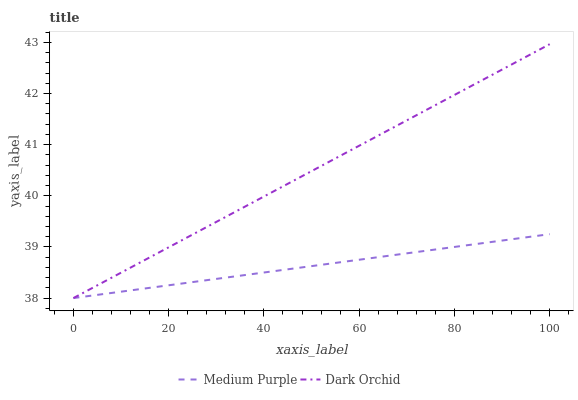Does Medium Purple have the minimum area under the curve?
Answer yes or no. Yes. Does Dark Orchid have the maximum area under the curve?
Answer yes or no. Yes. Does Dark Orchid have the minimum area under the curve?
Answer yes or no. No. Is Medium Purple the smoothest?
Answer yes or no. Yes. Is Dark Orchid the roughest?
Answer yes or no. Yes. Is Dark Orchid the smoothest?
Answer yes or no. No. Does Medium Purple have the lowest value?
Answer yes or no. Yes. Does Dark Orchid have the highest value?
Answer yes or no. Yes. Does Dark Orchid intersect Medium Purple?
Answer yes or no. Yes. Is Dark Orchid less than Medium Purple?
Answer yes or no. No. Is Dark Orchid greater than Medium Purple?
Answer yes or no. No. 